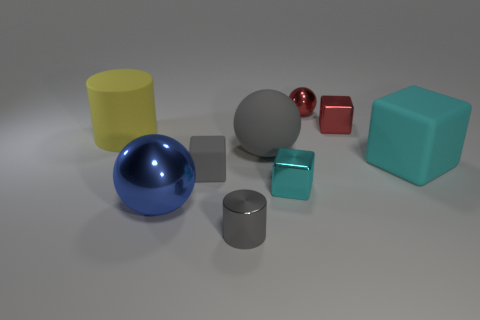Can you describe the colors and shapes of the objects in this image? Certainly! The image showcases a collection of geometric objects including two cylinders (one gray, one yellow), two cubes (one red, one cyan), and three spheres (one blue, one red, and one gray). Each object boasts a distinct, solid color and is rendered with a matte or slightly reflective surface. 